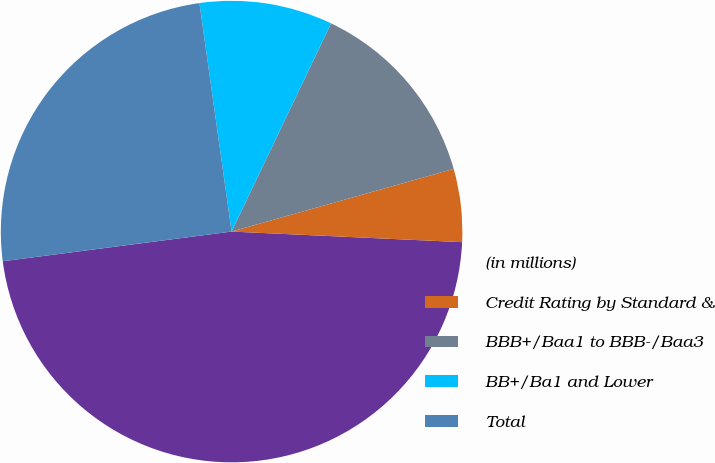<chart> <loc_0><loc_0><loc_500><loc_500><pie_chart><fcel>(in millions)<fcel>Credit Rating by Standard &<fcel>BBB+/Baa1 to BBB-/Baa3<fcel>BB+/Ba1 and Lower<fcel>Total<nl><fcel>47.22%<fcel>5.11%<fcel>13.53%<fcel>9.32%<fcel>24.83%<nl></chart> 